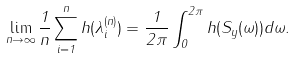Convert formula to latex. <formula><loc_0><loc_0><loc_500><loc_500>\lim _ { n \rightarrow \infty } \frac { 1 } { n } \sum _ { i = 1 } ^ { n } h ( \lambda _ { i } ^ { ( n ) } ) = \frac { 1 } { 2 \pi } \int _ { 0 } ^ { 2 \pi } h ( S _ { y } ( \omega ) ) d \omega .</formula> 